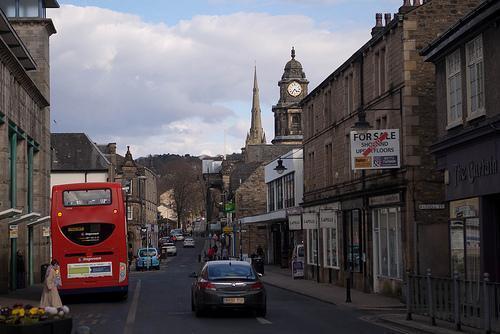How many buses are in the scene?
Give a very brief answer. 1. 